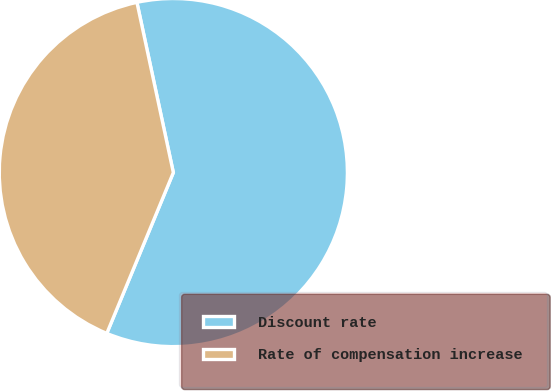Convert chart. <chart><loc_0><loc_0><loc_500><loc_500><pie_chart><fcel>Discount rate<fcel>Rate of compensation increase<nl><fcel>59.6%<fcel>40.4%<nl></chart> 